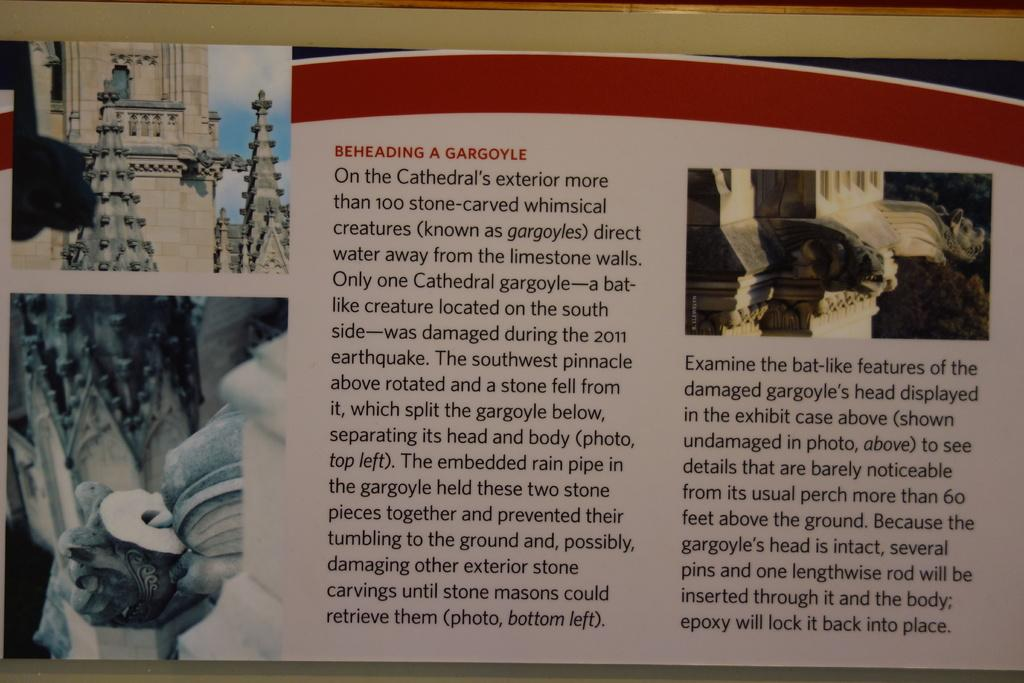<image>
Relay a brief, clear account of the picture shown. PAGES OF A BOOK WITH PICTURES WITH A STORY ABOUT BEHEADING GARGOYLE 